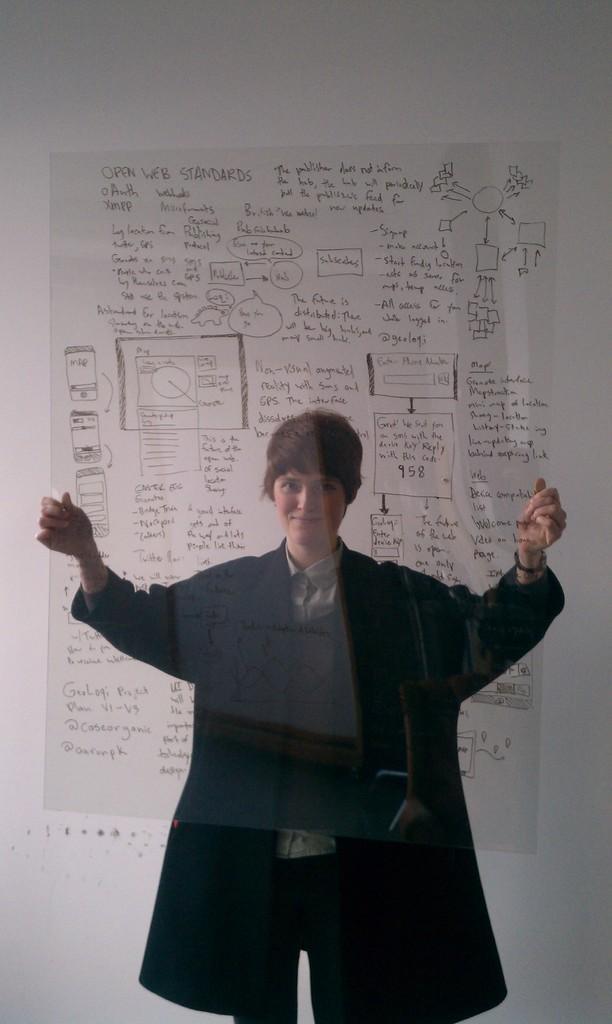In one or two sentences, can you explain what this image depicts? In this image in front there is a person holding the transparent sheet. In the background of the image there is a wall. 